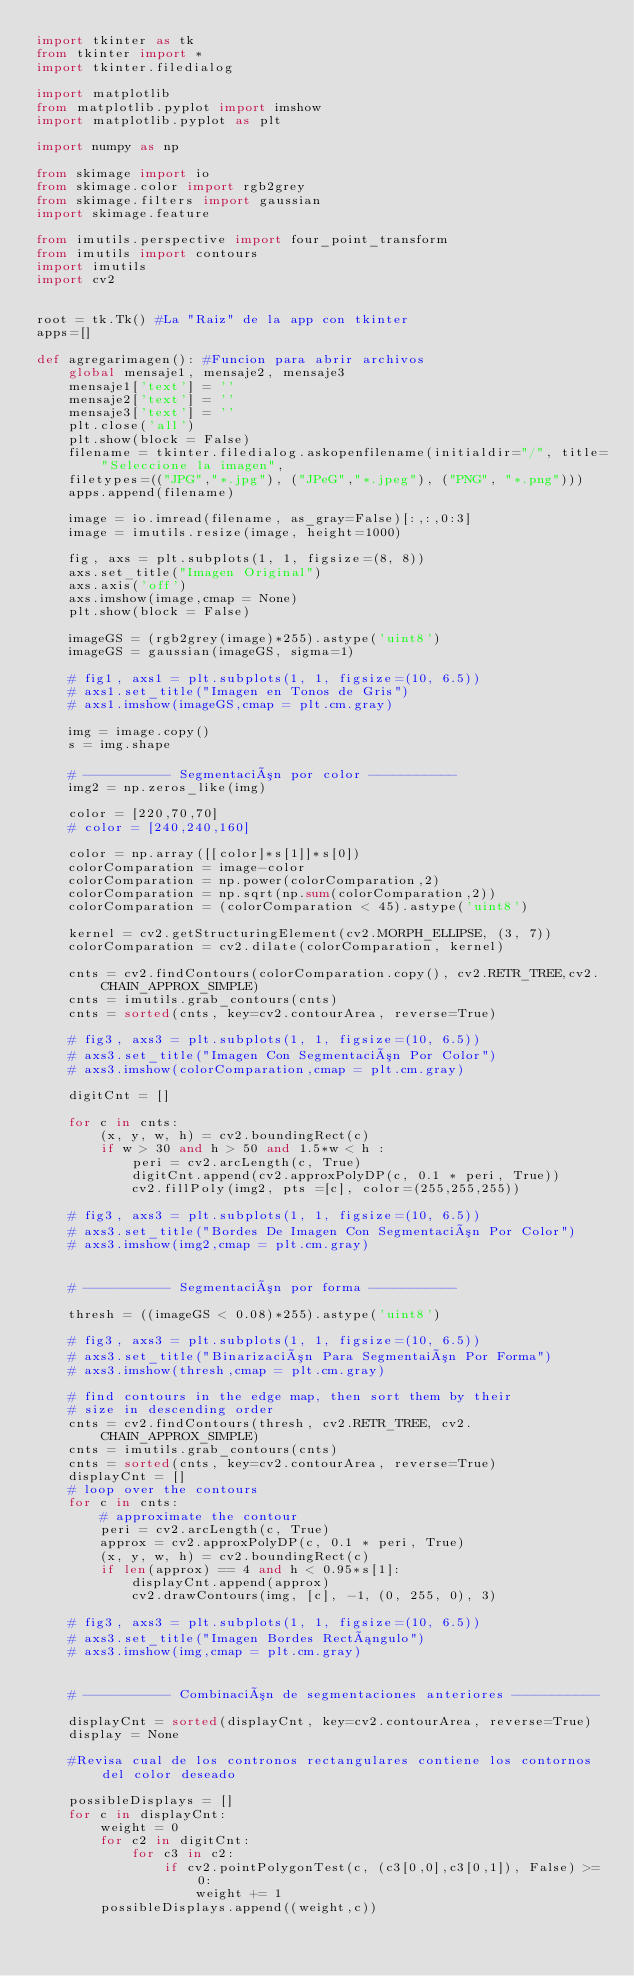<code> <loc_0><loc_0><loc_500><loc_500><_Python_>import tkinter as tk
from tkinter import *
import tkinter.filedialog

import matplotlib
from matplotlib.pyplot import imshow
import matplotlib.pyplot as plt

import numpy as np

from skimage import io
from skimage.color import rgb2grey
from skimage.filters import gaussian
import skimage.feature

from imutils.perspective import four_point_transform
from imutils import contours
import imutils
import cv2


root = tk.Tk() #La "Raiz" de la app con tkinter
apps=[]

def agregarimagen(): #Funcion para abrir archivos
    global mensaje1, mensaje2, mensaje3
    mensaje1['text'] = ''
    mensaje2['text'] = ''
    mensaje3['text'] = ''
    plt.close('all')
    plt.show(block = False)
    filename = tkinter.filedialog.askopenfilename(initialdir="/", title="Seleccione la imagen",
    filetypes=(("JPG","*.jpg"), ("JPeG","*.jpeg"), ("PNG", "*.png")))
    apps.append(filename)
    
    image = io.imread(filename, as_gray=False)[:,:,0:3]
    image = imutils.resize(image, height=1000)

    fig, axs = plt.subplots(1, 1, figsize=(8, 8))
    axs.set_title("Imagen Original")
    axs.axis('off')
    axs.imshow(image,cmap = None)
    plt.show(block = False)
    
    imageGS = (rgb2grey(image)*255).astype('uint8')
    imageGS = gaussian(imageGS, sigma=1)

    # fig1, axs1 = plt.subplots(1, 1, figsize=(10, 6.5))
    # axs1.set_title("Imagen en Tonos de Gris")
    # axs1.imshow(imageGS,cmap = plt.cm.gray)

    img = image.copy()
    s = img.shape

    # ----------- Segmentación por color -----------
    img2 = np.zeros_like(img)

    color = [220,70,70]
    # color = [240,240,160]

    color = np.array([[color]*s[1]]*s[0])
    colorComparation = image-color
    colorComparation = np.power(colorComparation,2)
    colorComparation = np.sqrt(np.sum(colorComparation,2))
    colorComparation = (colorComparation < 45).astype('uint8')

    kernel = cv2.getStructuringElement(cv2.MORPH_ELLIPSE, (3, 7))
    colorComparation = cv2.dilate(colorComparation, kernel)

    cnts = cv2.findContours(colorComparation.copy(), cv2.RETR_TREE,cv2.CHAIN_APPROX_SIMPLE)
    cnts = imutils.grab_contours(cnts)
    cnts = sorted(cnts, key=cv2.contourArea, reverse=True)

    # fig3, axs3 = plt.subplots(1, 1, figsize=(10, 6.5))
    # axs3.set_title("Imagen Con Segmentación Por Color")
    # axs3.imshow(colorComparation,cmap = plt.cm.gray)

    digitCnt = []

    for c in cnts:
        (x, y, w, h) = cv2.boundingRect(c)
        if w > 30 and h > 50 and 1.5*w < h :
            peri = cv2.arcLength(c, True)
            digitCnt.append(cv2.approxPolyDP(c, 0.1 * peri, True))
            cv2.fillPoly(img2, pts =[c], color=(255,255,255))

    # fig3, axs3 = plt.subplots(1, 1, figsize=(10, 6.5))
    # axs3.set_title("Bordes De Imagen Con Segmentación Por Color")
    # axs3.imshow(img2,cmap = plt.cm.gray)


    # ----------- Segmentación por forma -----------

    thresh = ((imageGS < 0.08)*255).astype('uint8')

    # fig3, axs3 = plt.subplots(1, 1, figsize=(10, 6.5))
    # axs3.set_title("Binarización Para Segmentaión Por Forma")
    # axs3.imshow(thresh,cmap = plt.cm.gray)

    # find contours in the edge map, then sort them by their
    # size in descending order
    cnts = cv2.findContours(thresh, cv2.RETR_TREE, cv2.CHAIN_APPROX_SIMPLE)
    cnts = imutils.grab_contours(cnts)
    cnts = sorted(cnts, key=cv2.contourArea, reverse=True)
    displayCnt = []
    # loop over the contours
    for c in cnts:
        # approximate the contour
        peri = cv2.arcLength(c, True)
        approx = cv2.approxPolyDP(c, 0.1 * peri, True)
        (x, y, w, h) = cv2.boundingRect(c)
        if len(approx) == 4 and h < 0.95*s[1]:
            displayCnt.append(approx)
            cv2.drawContours(img, [c], -1, (0, 255, 0), 3)

    # fig3, axs3 = plt.subplots(1, 1, figsize=(10, 6.5))
    # axs3.set_title("Imagen Bordes Rectángulo")
    # axs3.imshow(img,cmap = plt.cm.gray)


    # ----------- Combinación de segmentaciones anteriores -----------

    displayCnt = sorted(displayCnt, key=cv2.contourArea, reverse=True)
    display = None

    #Revisa cual de los contronos rectangulares contiene los contornos del color deseado

    possibleDisplays = []
    for c in displayCnt:
        weight = 0
        for c2 in digitCnt:
            for c3 in c2:
                if cv2.pointPolygonTest(c, (c3[0,0],c3[0,1]), False) >= 0:
                    weight += 1
        possibleDisplays.append((weight,c))
</code> 